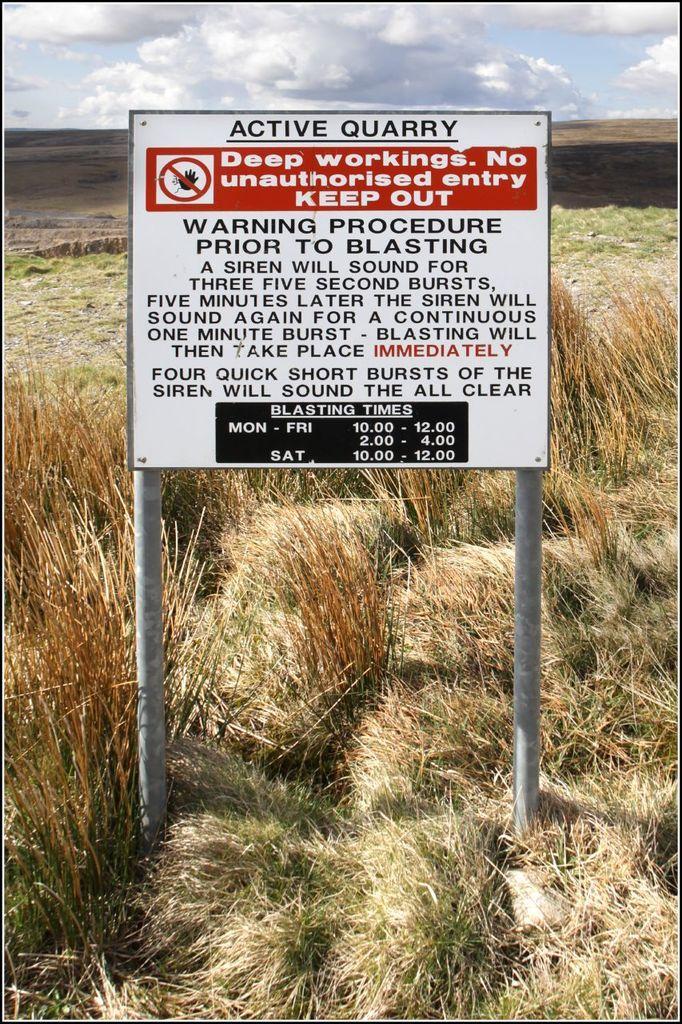How would you summarize this image in a sentence or two? In this image we can see a board with poles. On the board there is some text. On the ground there is grass. In the background there is sky with clouds. 